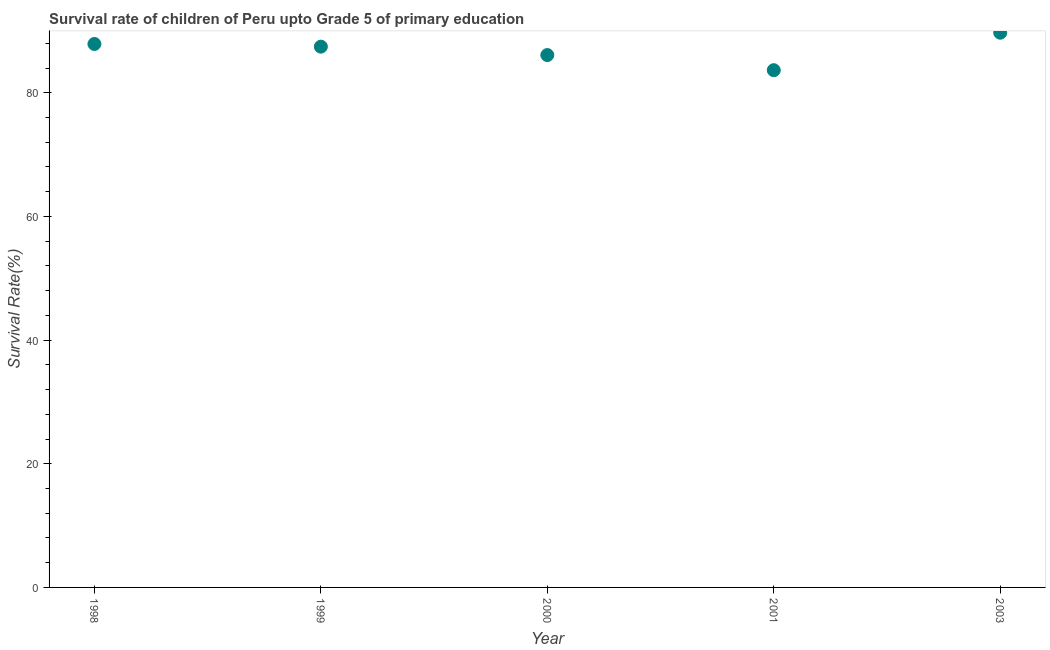What is the survival rate in 2001?
Offer a terse response. 83.65. Across all years, what is the maximum survival rate?
Your answer should be compact. 89.72. Across all years, what is the minimum survival rate?
Offer a terse response. 83.65. In which year was the survival rate maximum?
Give a very brief answer. 2003. What is the sum of the survival rate?
Ensure brevity in your answer.  434.83. What is the difference between the survival rate in 1999 and 2001?
Your response must be concise. 3.81. What is the average survival rate per year?
Make the answer very short. 86.97. What is the median survival rate?
Your answer should be very brief. 87.46. What is the ratio of the survival rate in 1998 to that in 2000?
Your answer should be compact. 1.02. Is the difference between the survival rate in 2001 and 2003 greater than the difference between any two years?
Offer a very short reply. Yes. What is the difference between the highest and the second highest survival rate?
Ensure brevity in your answer.  1.82. Is the sum of the survival rate in 1999 and 2003 greater than the maximum survival rate across all years?
Ensure brevity in your answer.  Yes. What is the difference between the highest and the lowest survival rate?
Your answer should be compact. 6.06. Does the survival rate monotonically increase over the years?
Your answer should be compact. No. Are the values on the major ticks of Y-axis written in scientific E-notation?
Provide a short and direct response. No. Does the graph contain grids?
Provide a short and direct response. No. What is the title of the graph?
Your response must be concise. Survival rate of children of Peru upto Grade 5 of primary education. What is the label or title of the Y-axis?
Provide a short and direct response. Survival Rate(%). What is the Survival Rate(%) in 1998?
Offer a terse response. 87.89. What is the Survival Rate(%) in 1999?
Offer a terse response. 87.46. What is the Survival Rate(%) in 2000?
Make the answer very short. 86.1. What is the Survival Rate(%) in 2001?
Your response must be concise. 83.65. What is the Survival Rate(%) in 2003?
Offer a very short reply. 89.72. What is the difference between the Survival Rate(%) in 1998 and 1999?
Offer a terse response. 0.43. What is the difference between the Survival Rate(%) in 1998 and 2000?
Your response must be concise. 1.79. What is the difference between the Survival Rate(%) in 1998 and 2001?
Give a very brief answer. 4.24. What is the difference between the Survival Rate(%) in 1998 and 2003?
Keep it short and to the point. -1.82. What is the difference between the Survival Rate(%) in 1999 and 2000?
Make the answer very short. 1.36. What is the difference between the Survival Rate(%) in 1999 and 2001?
Offer a terse response. 3.81. What is the difference between the Survival Rate(%) in 1999 and 2003?
Your answer should be very brief. -2.25. What is the difference between the Survival Rate(%) in 2000 and 2001?
Keep it short and to the point. 2.45. What is the difference between the Survival Rate(%) in 2000 and 2003?
Provide a succinct answer. -3.62. What is the difference between the Survival Rate(%) in 2001 and 2003?
Your answer should be compact. -6.06. What is the ratio of the Survival Rate(%) in 1998 to that in 1999?
Your response must be concise. 1. What is the ratio of the Survival Rate(%) in 1998 to that in 2001?
Make the answer very short. 1.05. What is the ratio of the Survival Rate(%) in 1998 to that in 2003?
Offer a very short reply. 0.98. What is the ratio of the Survival Rate(%) in 1999 to that in 2000?
Offer a terse response. 1.02. What is the ratio of the Survival Rate(%) in 1999 to that in 2001?
Give a very brief answer. 1.05. What is the ratio of the Survival Rate(%) in 2001 to that in 2003?
Your answer should be very brief. 0.93. 